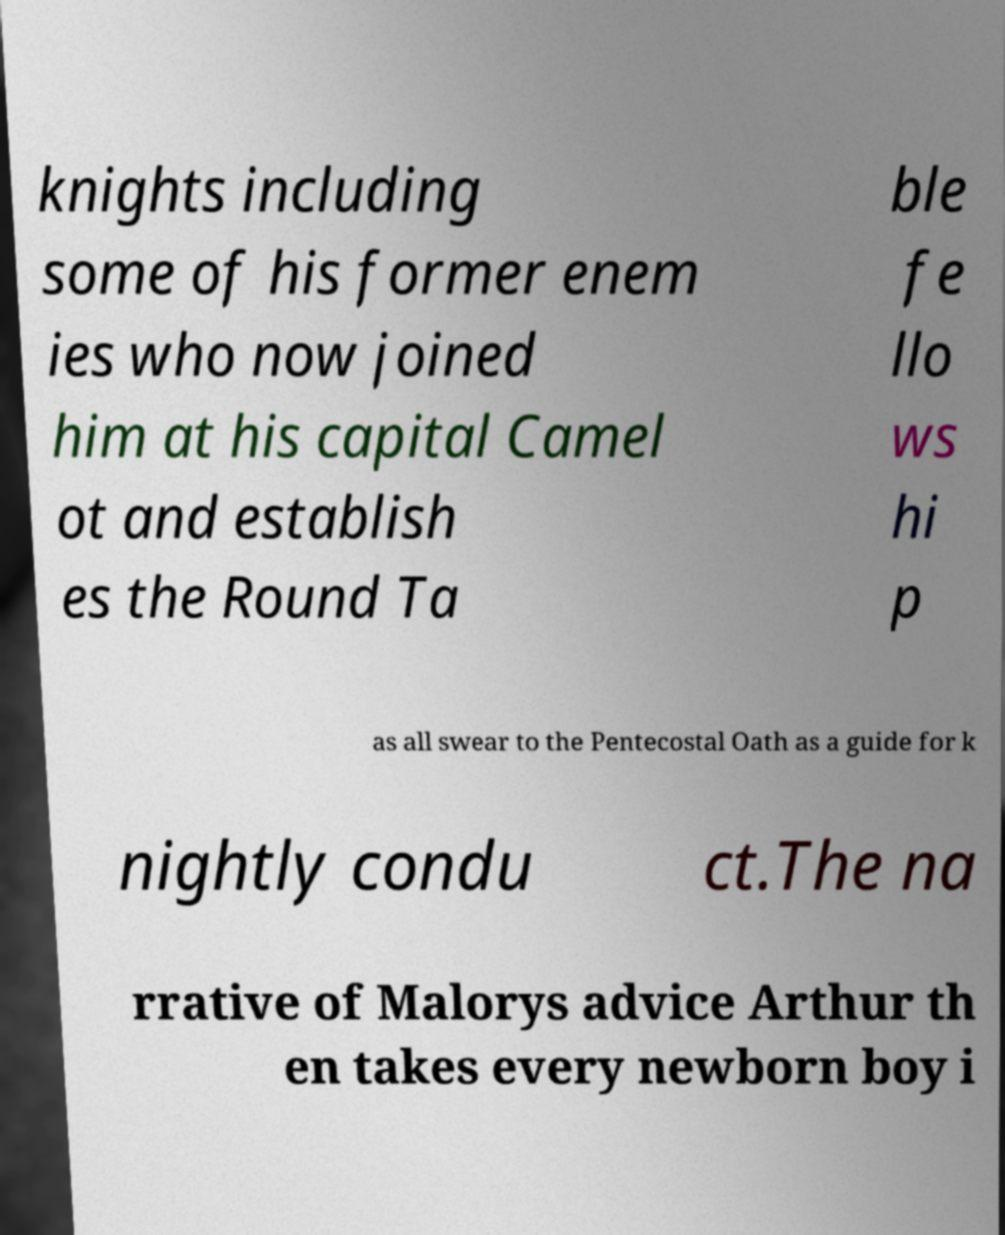Please identify and transcribe the text found in this image. knights including some of his former enem ies who now joined him at his capital Camel ot and establish es the Round Ta ble fe llo ws hi p as all swear to the Pentecostal Oath as a guide for k nightly condu ct.The na rrative of Malorys advice Arthur th en takes every newborn boy i 